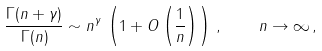<formula> <loc_0><loc_0><loc_500><loc_500>\frac { \Gamma ( n + \gamma ) } { \Gamma ( n ) } \sim n ^ { \gamma } \, \left ( 1 + O \left ( \frac { 1 } { n } \right ) \right ) \, , \quad n \to \infty \, ,</formula> 